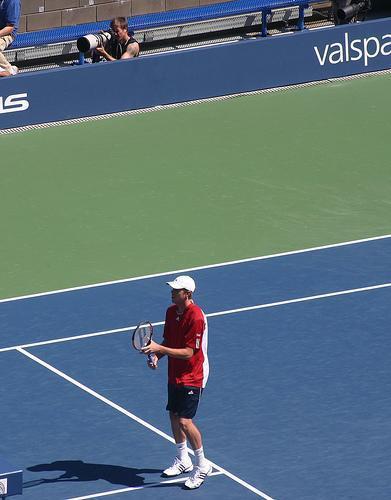How many rackets is the player holding?
Give a very brief answer. 1. 